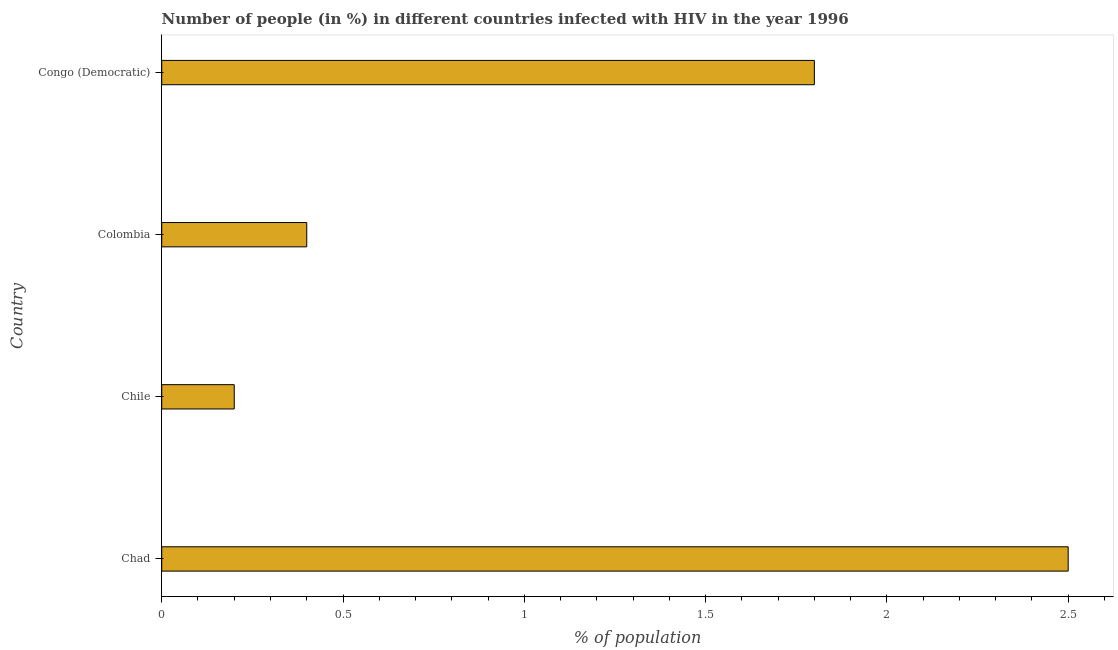Does the graph contain any zero values?
Ensure brevity in your answer.  No. Does the graph contain grids?
Ensure brevity in your answer.  No. What is the title of the graph?
Make the answer very short. Number of people (in %) in different countries infected with HIV in the year 1996. What is the label or title of the X-axis?
Your answer should be compact. % of population. In which country was the number of people infected with hiv maximum?
Keep it short and to the point. Chad. In which country was the number of people infected with hiv minimum?
Ensure brevity in your answer.  Chile. What is the sum of the number of people infected with hiv?
Give a very brief answer. 4.9. What is the average number of people infected with hiv per country?
Your response must be concise. 1.23. What is the ratio of the number of people infected with hiv in Chad to that in Chile?
Your answer should be compact. 12.5. Is the number of people infected with hiv in Chad less than that in Congo (Democratic)?
Give a very brief answer. No. In how many countries, is the number of people infected with hiv greater than the average number of people infected with hiv taken over all countries?
Keep it short and to the point. 2. Are all the bars in the graph horizontal?
Ensure brevity in your answer.  Yes. Are the values on the major ticks of X-axis written in scientific E-notation?
Ensure brevity in your answer.  No. What is the % of population in Chile?
Provide a short and direct response. 0.2. What is the % of population of Colombia?
Make the answer very short. 0.4. What is the difference between the % of population in Chad and Colombia?
Give a very brief answer. 2.1. What is the difference between the % of population in Chad and Congo (Democratic)?
Make the answer very short. 0.7. What is the difference between the % of population in Chile and Congo (Democratic)?
Keep it short and to the point. -1.6. What is the difference between the % of population in Colombia and Congo (Democratic)?
Make the answer very short. -1.4. What is the ratio of the % of population in Chad to that in Colombia?
Keep it short and to the point. 6.25. What is the ratio of the % of population in Chad to that in Congo (Democratic)?
Ensure brevity in your answer.  1.39. What is the ratio of the % of population in Chile to that in Congo (Democratic)?
Offer a very short reply. 0.11. What is the ratio of the % of population in Colombia to that in Congo (Democratic)?
Offer a very short reply. 0.22. 